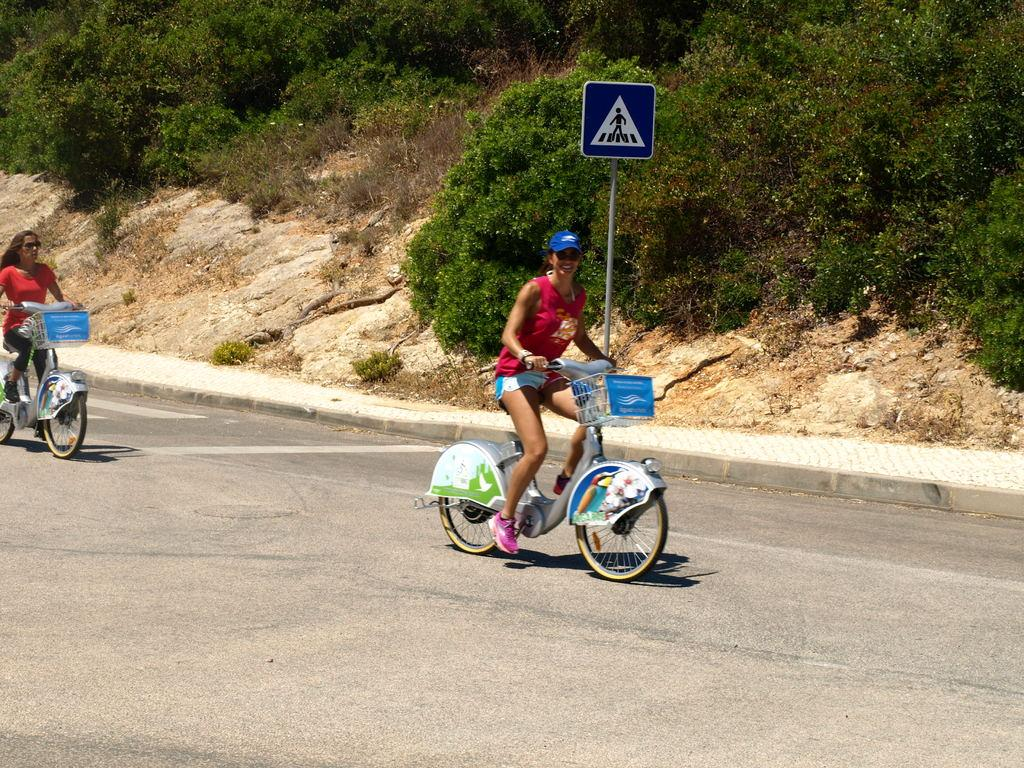How many people are in the image? There are two people in the image. What are the people doing in the image? The people are sitting on bicycles. What can be seen in the background of the image? There are stones and trees in the background of the image. What type of surface is visible in the image? There is a road visible in the image. What type of fire can be seen in the image? There is no fire present in the image. How does the anger of the people on the bicycles manifest in the image? There is no indication of anger in the image; the people are simply sitting on bicycles. 